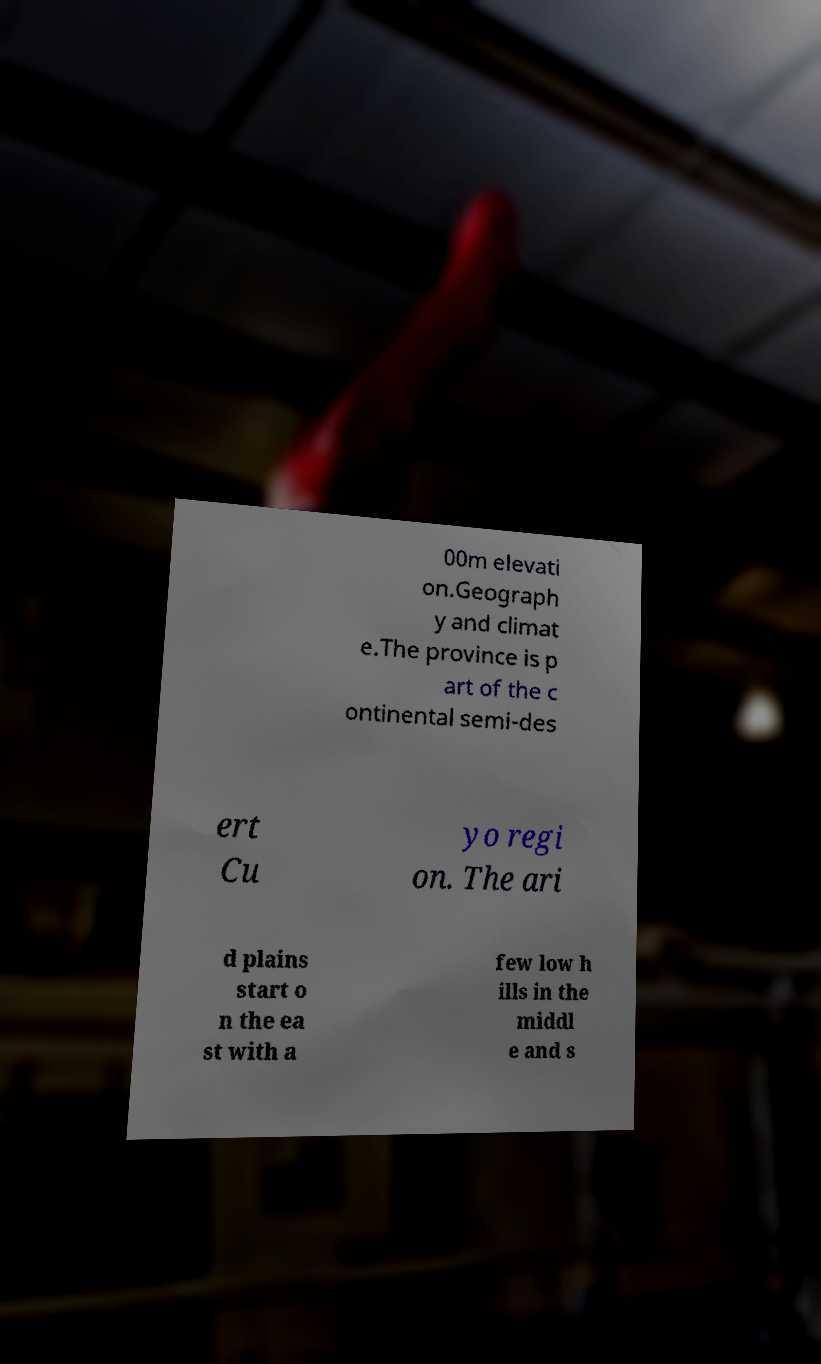Please identify and transcribe the text found in this image. 00m elevati on.Geograph y and climat e.The province is p art of the c ontinental semi-des ert Cu yo regi on. The ari d plains start o n the ea st with a few low h ills in the middl e and s 